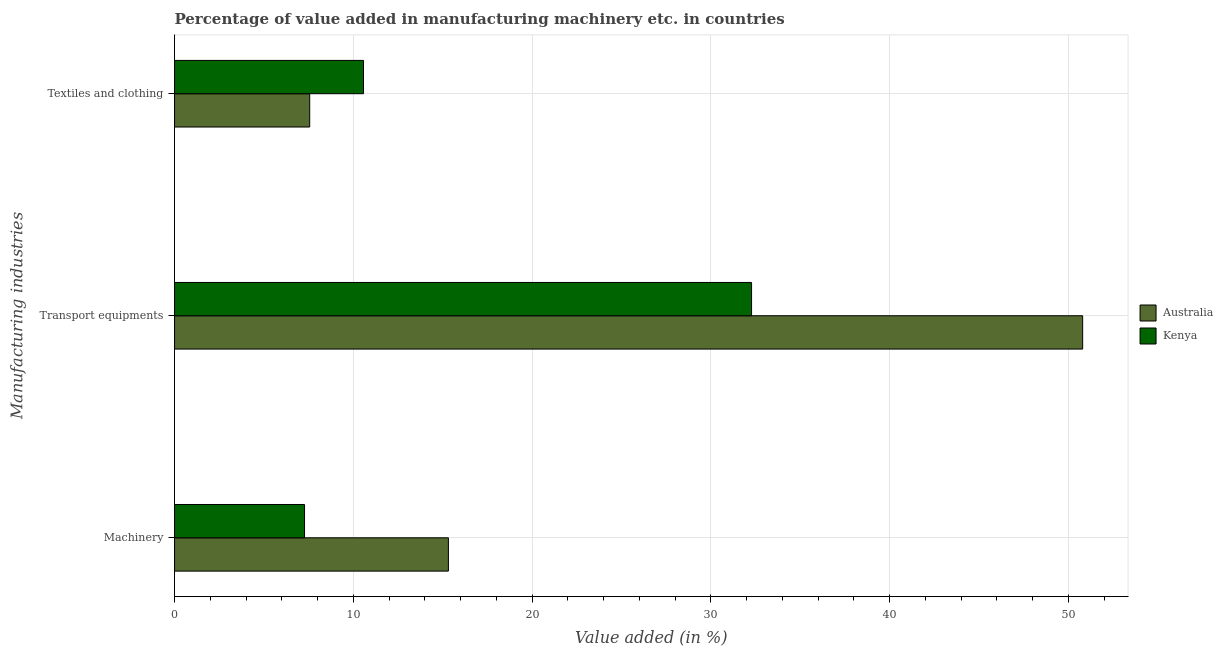Are the number of bars on each tick of the Y-axis equal?
Ensure brevity in your answer.  Yes. How many bars are there on the 2nd tick from the bottom?
Offer a very short reply. 2. What is the label of the 3rd group of bars from the top?
Offer a very short reply. Machinery. What is the value added in manufacturing transport equipments in Kenya?
Provide a succinct answer. 32.28. Across all countries, what is the maximum value added in manufacturing textile and clothing?
Make the answer very short. 10.57. Across all countries, what is the minimum value added in manufacturing transport equipments?
Provide a succinct answer. 32.28. In which country was the value added in manufacturing textile and clothing maximum?
Keep it short and to the point. Kenya. In which country was the value added in manufacturing transport equipments minimum?
Keep it short and to the point. Kenya. What is the total value added in manufacturing transport equipments in the graph?
Offer a terse response. 83.09. What is the difference between the value added in manufacturing machinery in Kenya and that in Australia?
Give a very brief answer. -8.05. What is the difference between the value added in manufacturing transport equipments in Australia and the value added in manufacturing textile and clothing in Kenya?
Provide a succinct answer. 40.23. What is the average value added in manufacturing transport equipments per country?
Your answer should be very brief. 41.54. What is the difference between the value added in manufacturing transport equipments and value added in manufacturing machinery in Kenya?
Your answer should be very brief. 25.01. What is the ratio of the value added in manufacturing transport equipments in Kenya to that in Australia?
Offer a very short reply. 0.64. Is the difference between the value added in manufacturing machinery in Australia and Kenya greater than the difference between the value added in manufacturing transport equipments in Australia and Kenya?
Make the answer very short. No. What is the difference between the highest and the second highest value added in manufacturing textile and clothing?
Provide a short and direct response. 3.01. What is the difference between the highest and the lowest value added in manufacturing textile and clothing?
Your answer should be compact. 3.01. Is the sum of the value added in manufacturing machinery in Australia and Kenya greater than the maximum value added in manufacturing transport equipments across all countries?
Give a very brief answer. No. What does the 1st bar from the bottom in Textiles and clothing represents?
Your answer should be compact. Australia. Is it the case that in every country, the sum of the value added in manufacturing machinery and value added in manufacturing transport equipments is greater than the value added in manufacturing textile and clothing?
Your answer should be very brief. Yes. Are all the bars in the graph horizontal?
Keep it short and to the point. Yes. What is the difference between two consecutive major ticks on the X-axis?
Your answer should be very brief. 10. Does the graph contain any zero values?
Provide a succinct answer. No. How are the legend labels stacked?
Your answer should be compact. Vertical. What is the title of the graph?
Make the answer very short. Percentage of value added in manufacturing machinery etc. in countries. What is the label or title of the X-axis?
Your answer should be compact. Value added (in %). What is the label or title of the Y-axis?
Provide a short and direct response. Manufacturing industries. What is the Value added (in %) of Australia in Machinery?
Provide a succinct answer. 15.32. What is the Value added (in %) of Kenya in Machinery?
Your answer should be compact. 7.27. What is the Value added (in %) of Australia in Transport equipments?
Provide a succinct answer. 50.8. What is the Value added (in %) of Kenya in Transport equipments?
Make the answer very short. 32.28. What is the Value added (in %) of Australia in Textiles and clothing?
Keep it short and to the point. 7.56. What is the Value added (in %) in Kenya in Textiles and clothing?
Ensure brevity in your answer.  10.57. Across all Manufacturing industries, what is the maximum Value added (in %) in Australia?
Your answer should be very brief. 50.8. Across all Manufacturing industries, what is the maximum Value added (in %) of Kenya?
Offer a terse response. 32.28. Across all Manufacturing industries, what is the minimum Value added (in %) of Australia?
Make the answer very short. 7.56. Across all Manufacturing industries, what is the minimum Value added (in %) in Kenya?
Your answer should be very brief. 7.27. What is the total Value added (in %) in Australia in the graph?
Make the answer very short. 73.69. What is the total Value added (in %) in Kenya in the graph?
Keep it short and to the point. 50.12. What is the difference between the Value added (in %) of Australia in Machinery and that in Transport equipments?
Ensure brevity in your answer.  -35.48. What is the difference between the Value added (in %) in Kenya in Machinery and that in Transport equipments?
Make the answer very short. -25.01. What is the difference between the Value added (in %) in Australia in Machinery and that in Textiles and clothing?
Make the answer very short. 7.76. What is the difference between the Value added (in %) of Kenya in Machinery and that in Textiles and clothing?
Your answer should be compact. -3.3. What is the difference between the Value added (in %) of Australia in Transport equipments and that in Textiles and clothing?
Keep it short and to the point. 43.24. What is the difference between the Value added (in %) in Kenya in Transport equipments and that in Textiles and clothing?
Your answer should be very brief. 21.71. What is the difference between the Value added (in %) of Australia in Machinery and the Value added (in %) of Kenya in Transport equipments?
Your answer should be very brief. -16.96. What is the difference between the Value added (in %) of Australia in Machinery and the Value added (in %) of Kenya in Textiles and clothing?
Offer a terse response. 4.75. What is the difference between the Value added (in %) of Australia in Transport equipments and the Value added (in %) of Kenya in Textiles and clothing?
Give a very brief answer. 40.23. What is the average Value added (in %) in Australia per Manufacturing industries?
Offer a very short reply. 24.56. What is the average Value added (in %) of Kenya per Manufacturing industries?
Offer a very short reply. 16.71. What is the difference between the Value added (in %) of Australia and Value added (in %) of Kenya in Machinery?
Your response must be concise. 8.05. What is the difference between the Value added (in %) of Australia and Value added (in %) of Kenya in Transport equipments?
Make the answer very short. 18.52. What is the difference between the Value added (in %) in Australia and Value added (in %) in Kenya in Textiles and clothing?
Offer a terse response. -3.01. What is the ratio of the Value added (in %) in Australia in Machinery to that in Transport equipments?
Your answer should be compact. 0.3. What is the ratio of the Value added (in %) of Kenya in Machinery to that in Transport equipments?
Offer a terse response. 0.23. What is the ratio of the Value added (in %) in Australia in Machinery to that in Textiles and clothing?
Provide a short and direct response. 2.03. What is the ratio of the Value added (in %) of Kenya in Machinery to that in Textiles and clothing?
Keep it short and to the point. 0.69. What is the ratio of the Value added (in %) in Australia in Transport equipments to that in Textiles and clothing?
Keep it short and to the point. 6.72. What is the ratio of the Value added (in %) of Kenya in Transport equipments to that in Textiles and clothing?
Provide a succinct answer. 3.05. What is the difference between the highest and the second highest Value added (in %) of Australia?
Give a very brief answer. 35.48. What is the difference between the highest and the second highest Value added (in %) of Kenya?
Keep it short and to the point. 21.71. What is the difference between the highest and the lowest Value added (in %) in Australia?
Provide a succinct answer. 43.24. What is the difference between the highest and the lowest Value added (in %) of Kenya?
Your answer should be very brief. 25.01. 